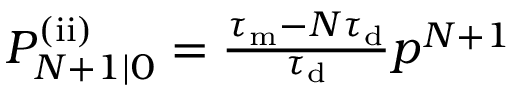<formula> <loc_0><loc_0><loc_500><loc_500>\begin{array} { r } { P _ { N + 1 | 0 } ^ { ( i i ) } = \frac { \tau _ { m } - N \tau _ { d } } { \tau _ { d } } p ^ { N + 1 } } \end{array}</formula> 